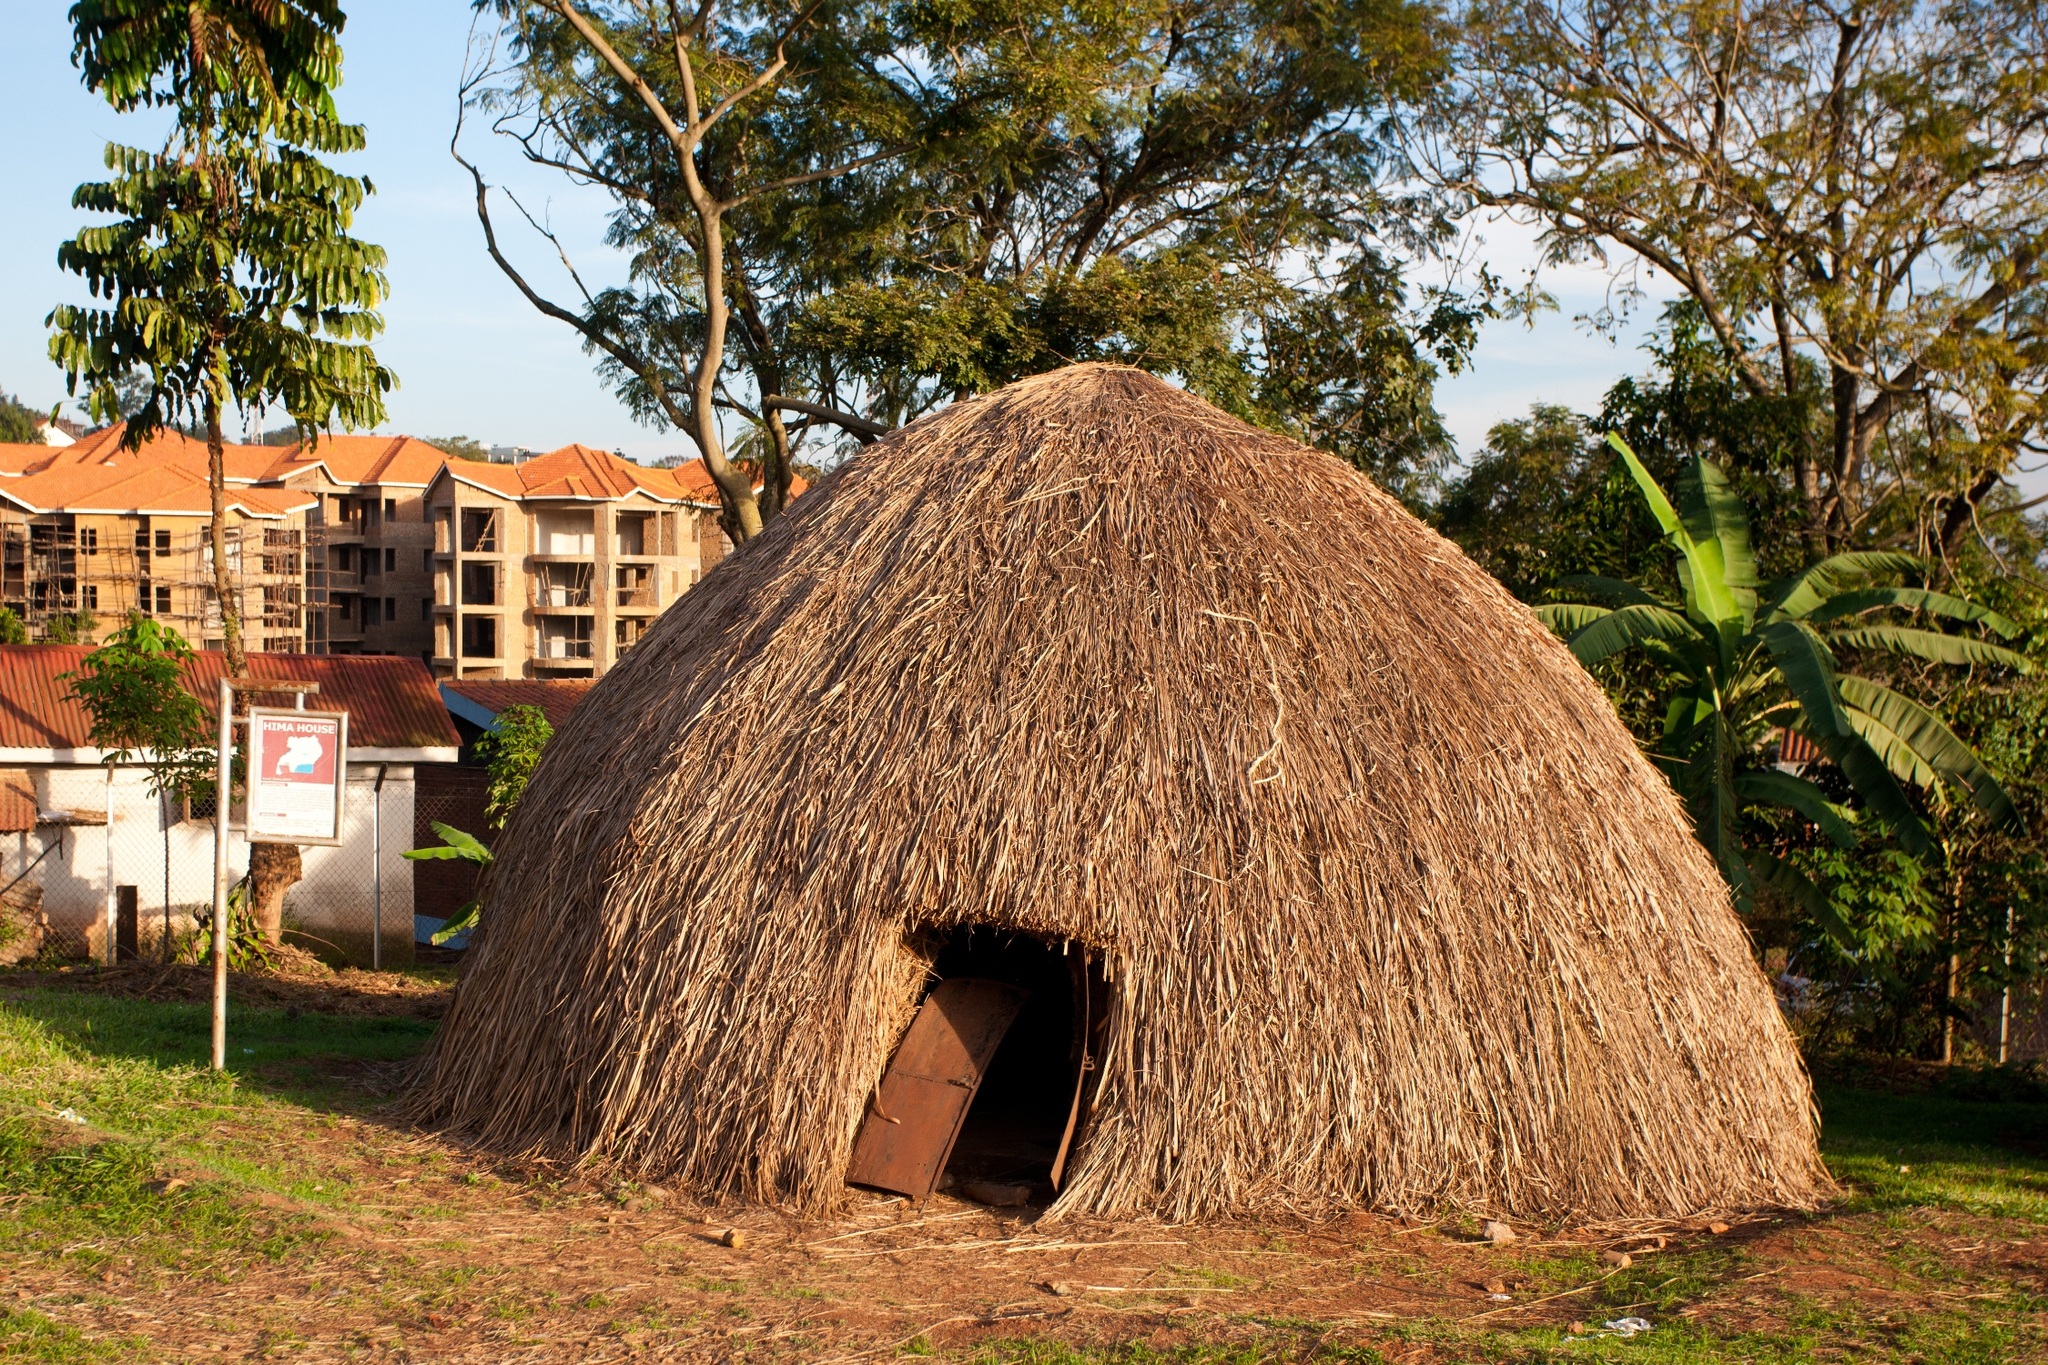Can you elaborate on the elements of the picture provided? Certainly! The image shows a traditional African hut made of thatched grass, emanating a sense of simplicity and cultural heritage. The hut, with its conical shape and brown hues, stands in a clearing above a dirt ground. Its wooden door suggests a modest lifestyle, harmoniously blended with the natural environment. Surrounding the hut is a vibrant green landscape, likely indicative of a fertile area. The background reveals a contrasting modern development, with buildings at various stages of construction. These elements together depict a juxtaposition of traditional rural life against the backdrop of urban expansion. Above, the clear blue sky suggests fair weather, creating a calm and serene atmosphere. 